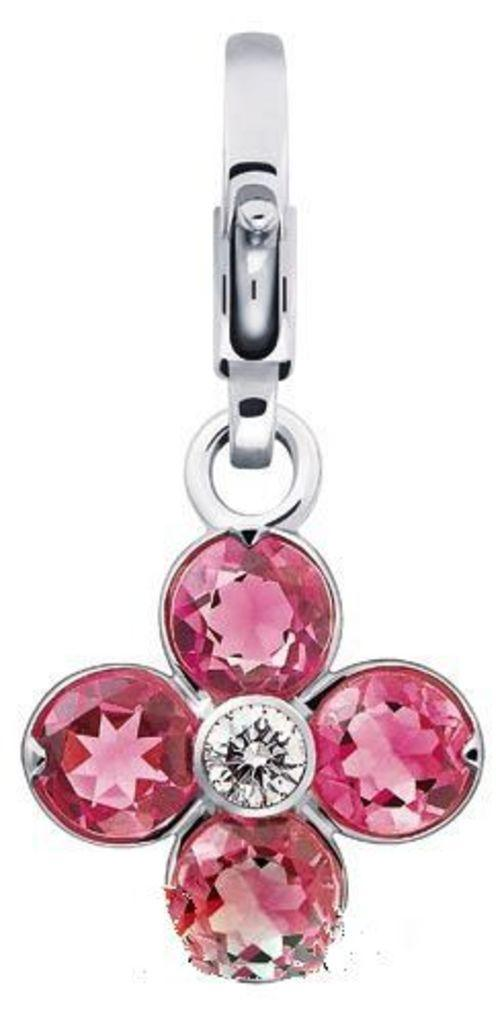What is the main object in the image? There is a locket in the image. What is special about the locket? The locket has pink stones. What type of cheese is visible in the image? There is no cheese present in the image. How big is the thumb in the image? There is no thumb present in the image. 